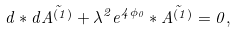<formula> <loc_0><loc_0><loc_500><loc_500>d * d \tilde { A ^ { ( 1 ) } } + { \lambda } ^ { 2 } e ^ { 4 \phi _ { 0 } } * \tilde { A ^ { ( 1 ) } } = 0 ,</formula> 